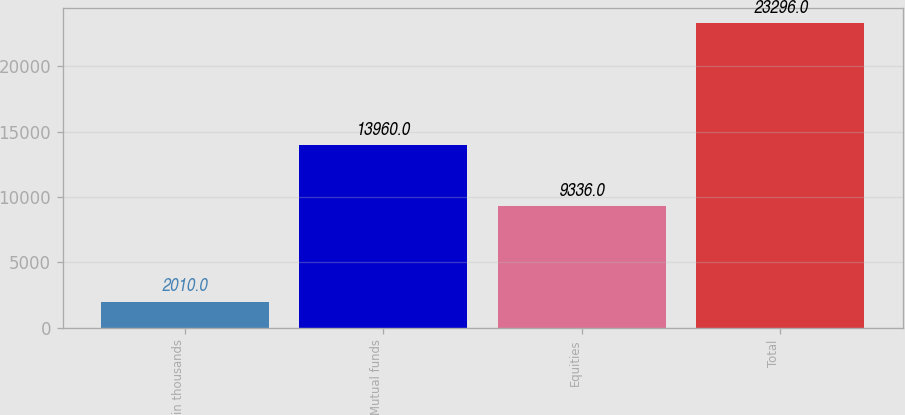Convert chart. <chart><loc_0><loc_0><loc_500><loc_500><bar_chart><fcel>in thousands<fcel>Mutual funds<fcel>Equities<fcel>Total<nl><fcel>2010<fcel>13960<fcel>9336<fcel>23296<nl></chart> 